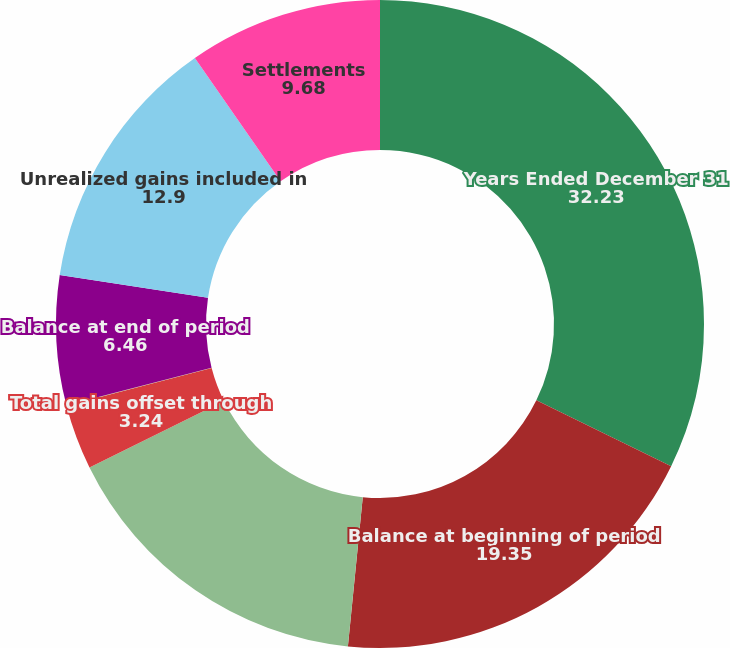Convert chart. <chart><loc_0><loc_0><loc_500><loc_500><pie_chart><fcel>Years Ended December 31<fcel>Balance at beginning of period<fcel>Total gains included in<fcel>Total gains offset through<fcel>Purchases<fcel>Balance at end of period<fcel>Unrealized gains included in<fcel>Settlements<nl><fcel>32.23%<fcel>19.35%<fcel>16.12%<fcel>3.24%<fcel>0.02%<fcel>6.46%<fcel>12.9%<fcel>9.68%<nl></chart> 